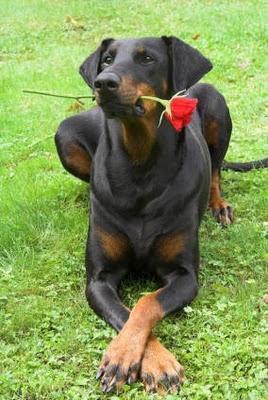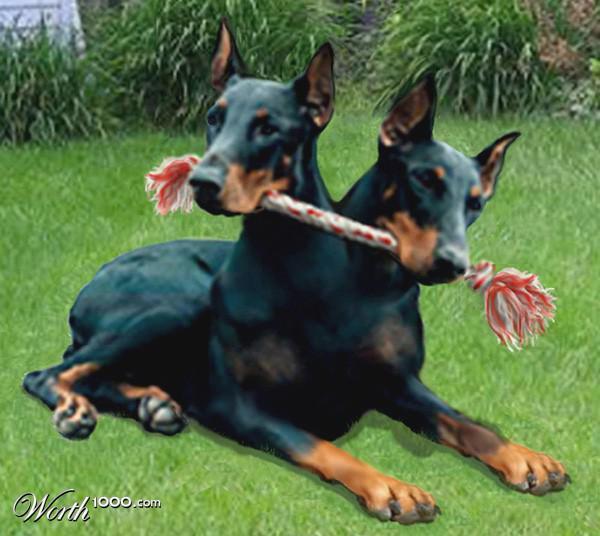The first image is the image on the left, the second image is the image on the right. Evaluate the accuracy of this statement regarding the images: "There are three dogs sitting or laying on the grass.". Is it true? Answer yes or no. Yes. 